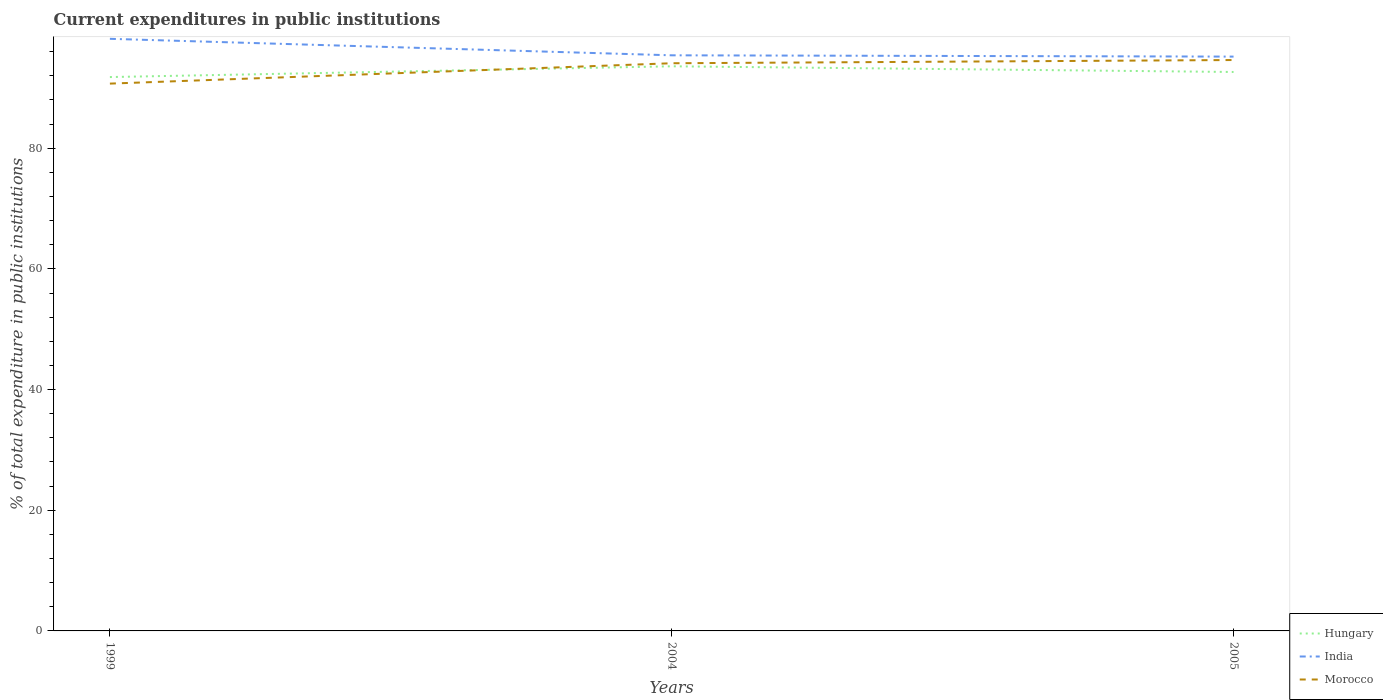How many different coloured lines are there?
Your answer should be compact. 3. Is the number of lines equal to the number of legend labels?
Offer a terse response. Yes. Across all years, what is the maximum current expenditures in public institutions in Morocco?
Keep it short and to the point. 90.71. In which year was the current expenditures in public institutions in Hungary maximum?
Make the answer very short. 1999. What is the total current expenditures in public institutions in Hungary in the graph?
Your response must be concise. -0.84. What is the difference between the highest and the second highest current expenditures in public institutions in Hungary?
Offer a terse response. 1.78. What is the difference between the highest and the lowest current expenditures in public institutions in India?
Give a very brief answer. 1. Is the current expenditures in public institutions in Morocco strictly greater than the current expenditures in public institutions in Hungary over the years?
Provide a succinct answer. No. What is the difference between two consecutive major ticks on the Y-axis?
Keep it short and to the point. 20. How are the legend labels stacked?
Offer a terse response. Vertical. What is the title of the graph?
Your answer should be compact. Current expenditures in public institutions. What is the label or title of the X-axis?
Your answer should be compact. Years. What is the label or title of the Y-axis?
Your answer should be very brief. % of total expenditure in public institutions. What is the % of total expenditure in public institutions of Hungary in 1999?
Offer a very short reply. 91.8. What is the % of total expenditure in public institutions of India in 1999?
Your answer should be compact. 98.13. What is the % of total expenditure in public institutions of Morocco in 1999?
Keep it short and to the point. 90.71. What is the % of total expenditure in public institutions in Hungary in 2004?
Offer a terse response. 93.58. What is the % of total expenditure in public institutions in India in 2004?
Offer a terse response. 95.4. What is the % of total expenditure in public institutions of Morocco in 2004?
Offer a terse response. 94.09. What is the % of total expenditure in public institutions in Hungary in 2005?
Provide a short and direct response. 92.64. What is the % of total expenditure in public institutions of India in 2005?
Your answer should be compact. 95.19. What is the % of total expenditure in public institutions of Morocco in 2005?
Offer a terse response. 94.62. Across all years, what is the maximum % of total expenditure in public institutions of Hungary?
Offer a very short reply. 93.58. Across all years, what is the maximum % of total expenditure in public institutions of India?
Your answer should be very brief. 98.13. Across all years, what is the maximum % of total expenditure in public institutions of Morocco?
Make the answer very short. 94.62. Across all years, what is the minimum % of total expenditure in public institutions in Hungary?
Provide a short and direct response. 91.8. Across all years, what is the minimum % of total expenditure in public institutions of India?
Offer a very short reply. 95.19. Across all years, what is the minimum % of total expenditure in public institutions in Morocco?
Offer a very short reply. 90.71. What is the total % of total expenditure in public institutions in Hungary in the graph?
Your response must be concise. 278.01. What is the total % of total expenditure in public institutions in India in the graph?
Offer a very short reply. 288.72. What is the total % of total expenditure in public institutions of Morocco in the graph?
Provide a succinct answer. 279.41. What is the difference between the % of total expenditure in public institutions in Hungary in 1999 and that in 2004?
Make the answer very short. -1.78. What is the difference between the % of total expenditure in public institutions in India in 1999 and that in 2004?
Keep it short and to the point. 2.73. What is the difference between the % of total expenditure in public institutions of Morocco in 1999 and that in 2004?
Keep it short and to the point. -3.38. What is the difference between the % of total expenditure in public institutions in Hungary in 1999 and that in 2005?
Offer a terse response. -0.84. What is the difference between the % of total expenditure in public institutions in India in 1999 and that in 2005?
Ensure brevity in your answer.  2.95. What is the difference between the % of total expenditure in public institutions of Morocco in 1999 and that in 2005?
Make the answer very short. -3.91. What is the difference between the % of total expenditure in public institutions of Hungary in 2004 and that in 2005?
Your response must be concise. 0.94. What is the difference between the % of total expenditure in public institutions of India in 2004 and that in 2005?
Give a very brief answer. 0.22. What is the difference between the % of total expenditure in public institutions of Morocco in 2004 and that in 2005?
Your answer should be very brief. -0.53. What is the difference between the % of total expenditure in public institutions in Hungary in 1999 and the % of total expenditure in public institutions in India in 2004?
Keep it short and to the point. -3.6. What is the difference between the % of total expenditure in public institutions of Hungary in 1999 and the % of total expenditure in public institutions of Morocco in 2004?
Offer a very short reply. -2.29. What is the difference between the % of total expenditure in public institutions in India in 1999 and the % of total expenditure in public institutions in Morocco in 2004?
Offer a very short reply. 4.05. What is the difference between the % of total expenditure in public institutions in Hungary in 1999 and the % of total expenditure in public institutions in India in 2005?
Your answer should be very brief. -3.39. What is the difference between the % of total expenditure in public institutions of Hungary in 1999 and the % of total expenditure in public institutions of Morocco in 2005?
Ensure brevity in your answer.  -2.82. What is the difference between the % of total expenditure in public institutions of India in 1999 and the % of total expenditure in public institutions of Morocco in 2005?
Give a very brief answer. 3.52. What is the difference between the % of total expenditure in public institutions in Hungary in 2004 and the % of total expenditure in public institutions in India in 2005?
Keep it short and to the point. -1.6. What is the difference between the % of total expenditure in public institutions of Hungary in 2004 and the % of total expenditure in public institutions of Morocco in 2005?
Offer a terse response. -1.04. What is the difference between the % of total expenditure in public institutions in India in 2004 and the % of total expenditure in public institutions in Morocco in 2005?
Keep it short and to the point. 0.78. What is the average % of total expenditure in public institutions of Hungary per year?
Your answer should be compact. 92.67. What is the average % of total expenditure in public institutions of India per year?
Make the answer very short. 96.24. What is the average % of total expenditure in public institutions of Morocco per year?
Your answer should be compact. 93.14. In the year 1999, what is the difference between the % of total expenditure in public institutions of Hungary and % of total expenditure in public institutions of India?
Offer a terse response. -6.34. In the year 1999, what is the difference between the % of total expenditure in public institutions in Hungary and % of total expenditure in public institutions in Morocco?
Your response must be concise. 1.09. In the year 1999, what is the difference between the % of total expenditure in public institutions of India and % of total expenditure in public institutions of Morocco?
Keep it short and to the point. 7.42. In the year 2004, what is the difference between the % of total expenditure in public institutions of Hungary and % of total expenditure in public institutions of India?
Offer a terse response. -1.82. In the year 2004, what is the difference between the % of total expenditure in public institutions of Hungary and % of total expenditure in public institutions of Morocco?
Your answer should be compact. -0.5. In the year 2004, what is the difference between the % of total expenditure in public institutions of India and % of total expenditure in public institutions of Morocco?
Give a very brief answer. 1.32. In the year 2005, what is the difference between the % of total expenditure in public institutions of Hungary and % of total expenditure in public institutions of India?
Your response must be concise. -2.55. In the year 2005, what is the difference between the % of total expenditure in public institutions in Hungary and % of total expenditure in public institutions in Morocco?
Your response must be concise. -1.98. In the year 2005, what is the difference between the % of total expenditure in public institutions in India and % of total expenditure in public institutions in Morocco?
Give a very brief answer. 0.57. What is the ratio of the % of total expenditure in public institutions of Hungary in 1999 to that in 2004?
Provide a short and direct response. 0.98. What is the ratio of the % of total expenditure in public institutions of India in 1999 to that in 2004?
Offer a terse response. 1.03. What is the ratio of the % of total expenditure in public institutions of Morocco in 1999 to that in 2004?
Your answer should be very brief. 0.96. What is the ratio of the % of total expenditure in public institutions of Hungary in 1999 to that in 2005?
Provide a short and direct response. 0.99. What is the ratio of the % of total expenditure in public institutions in India in 1999 to that in 2005?
Offer a very short reply. 1.03. What is the ratio of the % of total expenditure in public institutions in Morocco in 1999 to that in 2005?
Offer a terse response. 0.96. What is the ratio of the % of total expenditure in public institutions in Hungary in 2004 to that in 2005?
Your response must be concise. 1.01. What is the ratio of the % of total expenditure in public institutions of Morocco in 2004 to that in 2005?
Provide a succinct answer. 0.99. What is the difference between the highest and the second highest % of total expenditure in public institutions in Hungary?
Provide a succinct answer. 0.94. What is the difference between the highest and the second highest % of total expenditure in public institutions of India?
Your response must be concise. 2.73. What is the difference between the highest and the second highest % of total expenditure in public institutions of Morocco?
Provide a short and direct response. 0.53. What is the difference between the highest and the lowest % of total expenditure in public institutions of Hungary?
Your response must be concise. 1.78. What is the difference between the highest and the lowest % of total expenditure in public institutions of India?
Offer a very short reply. 2.95. What is the difference between the highest and the lowest % of total expenditure in public institutions in Morocco?
Ensure brevity in your answer.  3.91. 